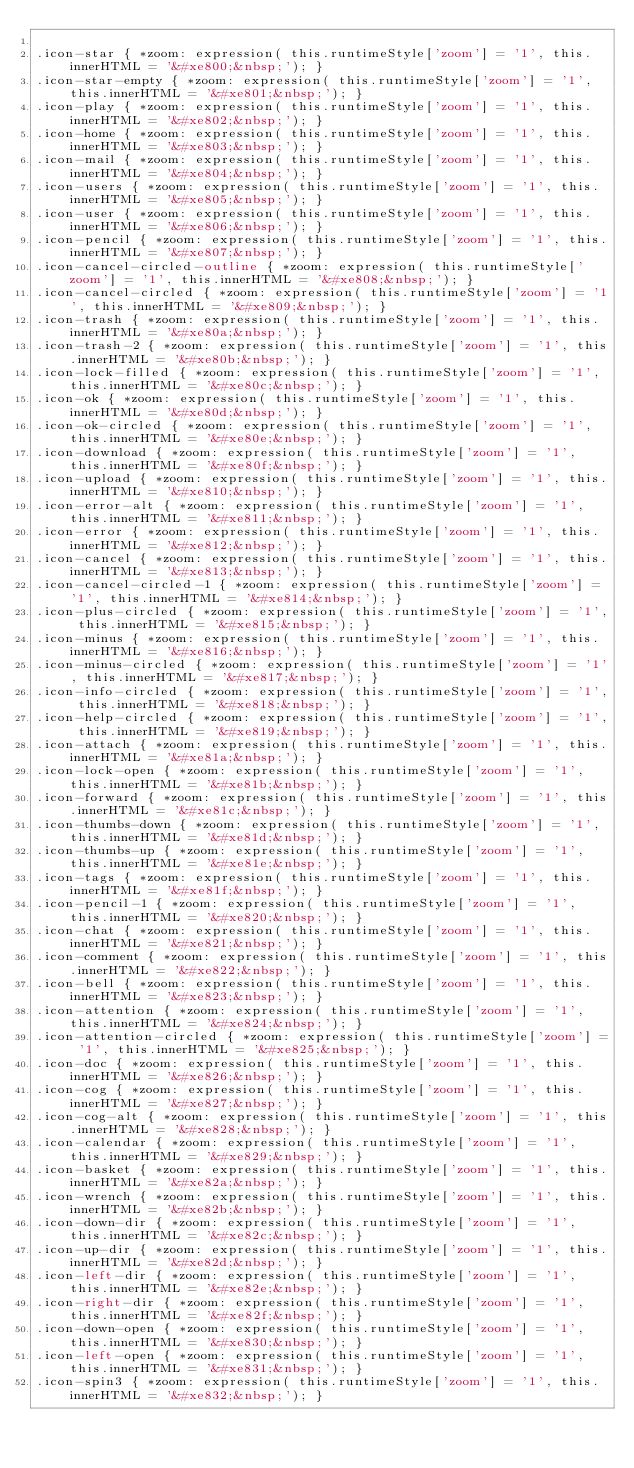<code> <loc_0><loc_0><loc_500><loc_500><_CSS_>
.icon-star { *zoom: expression( this.runtimeStyle['zoom'] = '1', this.innerHTML = '&#xe800;&nbsp;'); }
.icon-star-empty { *zoom: expression( this.runtimeStyle['zoom'] = '1', this.innerHTML = '&#xe801;&nbsp;'); }
.icon-play { *zoom: expression( this.runtimeStyle['zoom'] = '1', this.innerHTML = '&#xe802;&nbsp;'); }
.icon-home { *zoom: expression( this.runtimeStyle['zoom'] = '1', this.innerHTML = '&#xe803;&nbsp;'); }
.icon-mail { *zoom: expression( this.runtimeStyle['zoom'] = '1', this.innerHTML = '&#xe804;&nbsp;'); }
.icon-users { *zoom: expression( this.runtimeStyle['zoom'] = '1', this.innerHTML = '&#xe805;&nbsp;'); }
.icon-user { *zoom: expression( this.runtimeStyle['zoom'] = '1', this.innerHTML = '&#xe806;&nbsp;'); }
.icon-pencil { *zoom: expression( this.runtimeStyle['zoom'] = '1', this.innerHTML = '&#xe807;&nbsp;'); }
.icon-cancel-circled-outline { *zoom: expression( this.runtimeStyle['zoom'] = '1', this.innerHTML = '&#xe808;&nbsp;'); }
.icon-cancel-circled { *zoom: expression( this.runtimeStyle['zoom'] = '1', this.innerHTML = '&#xe809;&nbsp;'); }
.icon-trash { *zoom: expression( this.runtimeStyle['zoom'] = '1', this.innerHTML = '&#xe80a;&nbsp;'); }
.icon-trash-2 { *zoom: expression( this.runtimeStyle['zoom'] = '1', this.innerHTML = '&#xe80b;&nbsp;'); }
.icon-lock-filled { *zoom: expression( this.runtimeStyle['zoom'] = '1', this.innerHTML = '&#xe80c;&nbsp;'); }
.icon-ok { *zoom: expression( this.runtimeStyle['zoom'] = '1', this.innerHTML = '&#xe80d;&nbsp;'); }
.icon-ok-circled { *zoom: expression( this.runtimeStyle['zoom'] = '1', this.innerHTML = '&#xe80e;&nbsp;'); }
.icon-download { *zoom: expression( this.runtimeStyle['zoom'] = '1', this.innerHTML = '&#xe80f;&nbsp;'); }
.icon-upload { *zoom: expression( this.runtimeStyle['zoom'] = '1', this.innerHTML = '&#xe810;&nbsp;'); }
.icon-error-alt { *zoom: expression( this.runtimeStyle['zoom'] = '1', this.innerHTML = '&#xe811;&nbsp;'); }
.icon-error { *zoom: expression( this.runtimeStyle['zoom'] = '1', this.innerHTML = '&#xe812;&nbsp;'); }
.icon-cancel { *zoom: expression( this.runtimeStyle['zoom'] = '1', this.innerHTML = '&#xe813;&nbsp;'); }
.icon-cancel-circled-1 { *zoom: expression( this.runtimeStyle['zoom'] = '1', this.innerHTML = '&#xe814;&nbsp;'); }
.icon-plus-circled { *zoom: expression( this.runtimeStyle['zoom'] = '1', this.innerHTML = '&#xe815;&nbsp;'); }
.icon-minus { *zoom: expression( this.runtimeStyle['zoom'] = '1', this.innerHTML = '&#xe816;&nbsp;'); }
.icon-minus-circled { *zoom: expression( this.runtimeStyle['zoom'] = '1', this.innerHTML = '&#xe817;&nbsp;'); }
.icon-info-circled { *zoom: expression( this.runtimeStyle['zoom'] = '1', this.innerHTML = '&#xe818;&nbsp;'); }
.icon-help-circled { *zoom: expression( this.runtimeStyle['zoom'] = '1', this.innerHTML = '&#xe819;&nbsp;'); }
.icon-attach { *zoom: expression( this.runtimeStyle['zoom'] = '1', this.innerHTML = '&#xe81a;&nbsp;'); }
.icon-lock-open { *zoom: expression( this.runtimeStyle['zoom'] = '1', this.innerHTML = '&#xe81b;&nbsp;'); }
.icon-forward { *zoom: expression( this.runtimeStyle['zoom'] = '1', this.innerHTML = '&#xe81c;&nbsp;'); }
.icon-thumbs-down { *zoom: expression( this.runtimeStyle['zoom'] = '1', this.innerHTML = '&#xe81d;&nbsp;'); }
.icon-thumbs-up { *zoom: expression( this.runtimeStyle['zoom'] = '1', this.innerHTML = '&#xe81e;&nbsp;'); }
.icon-tags { *zoom: expression( this.runtimeStyle['zoom'] = '1', this.innerHTML = '&#xe81f;&nbsp;'); }
.icon-pencil-1 { *zoom: expression( this.runtimeStyle['zoom'] = '1', this.innerHTML = '&#xe820;&nbsp;'); }
.icon-chat { *zoom: expression( this.runtimeStyle['zoom'] = '1', this.innerHTML = '&#xe821;&nbsp;'); }
.icon-comment { *zoom: expression( this.runtimeStyle['zoom'] = '1', this.innerHTML = '&#xe822;&nbsp;'); }
.icon-bell { *zoom: expression( this.runtimeStyle['zoom'] = '1', this.innerHTML = '&#xe823;&nbsp;'); }
.icon-attention { *zoom: expression( this.runtimeStyle['zoom'] = '1', this.innerHTML = '&#xe824;&nbsp;'); }
.icon-attention-circled { *zoom: expression( this.runtimeStyle['zoom'] = '1', this.innerHTML = '&#xe825;&nbsp;'); }
.icon-doc { *zoom: expression( this.runtimeStyle['zoom'] = '1', this.innerHTML = '&#xe826;&nbsp;'); }
.icon-cog { *zoom: expression( this.runtimeStyle['zoom'] = '1', this.innerHTML = '&#xe827;&nbsp;'); }
.icon-cog-alt { *zoom: expression( this.runtimeStyle['zoom'] = '1', this.innerHTML = '&#xe828;&nbsp;'); }
.icon-calendar { *zoom: expression( this.runtimeStyle['zoom'] = '1', this.innerHTML = '&#xe829;&nbsp;'); }
.icon-basket { *zoom: expression( this.runtimeStyle['zoom'] = '1', this.innerHTML = '&#xe82a;&nbsp;'); }
.icon-wrench { *zoom: expression( this.runtimeStyle['zoom'] = '1', this.innerHTML = '&#xe82b;&nbsp;'); }
.icon-down-dir { *zoom: expression( this.runtimeStyle['zoom'] = '1', this.innerHTML = '&#xe82c;&nbsp;'); }
.icon-up-dir { *zoom: expression( this.runtimeStyle['zoom'] = '1', this.innerHTML = '&#xe82d;&nbsp;'); }
.icon-left-dir { *zoom: expression( this.runtimeStyle['zoom'] = '1', this.innerHTML = '&#xe82e;&nbsp;'); }
.icon-right-dir { *zoom: expression( this.runtimeStyle['zoom'] = '1', this.innerHTML = '&#xe82f;&nbsp;'); }
.icon-down-open { *zoom: expression( this.runtimeStyle['zoom'] = '1', this.innerHTML = '&#xe830;&nbsp;'); }
.icon-left-open { *zoom: expression( this.runtimeStyle['zoom'] = '1', this.innerHTML = '&#xe831;&nbsp;'); }
.icon-spin3 { *zoom: expression( this.runtimeStyle['zoom'] = '1', this.innerHTML = '&#xe832;&nbsp;'); }</code> 